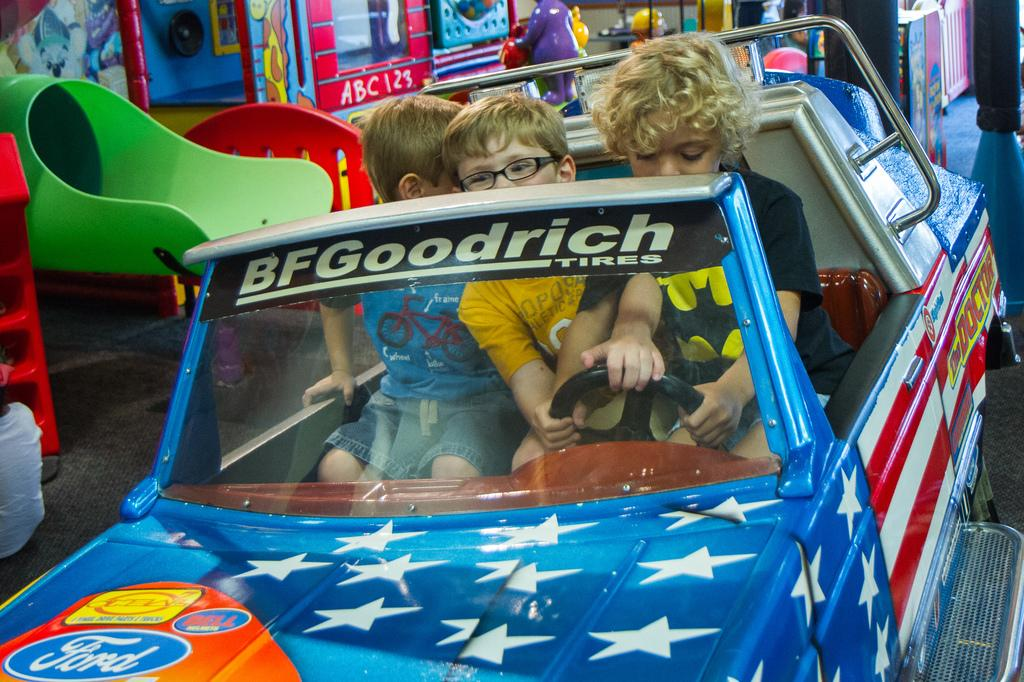How many children are present in the image? There are three children in the image. What are the children doing in the image? The children are sitting in a toy car. Where are the children located in the image? The children are in a play station, as indicated by the surroundings. What type of clock can be seen in the image? There is no clock present in the image. Can you tell me which child is playing the guitar in the image? There is no guitar present in the image. 